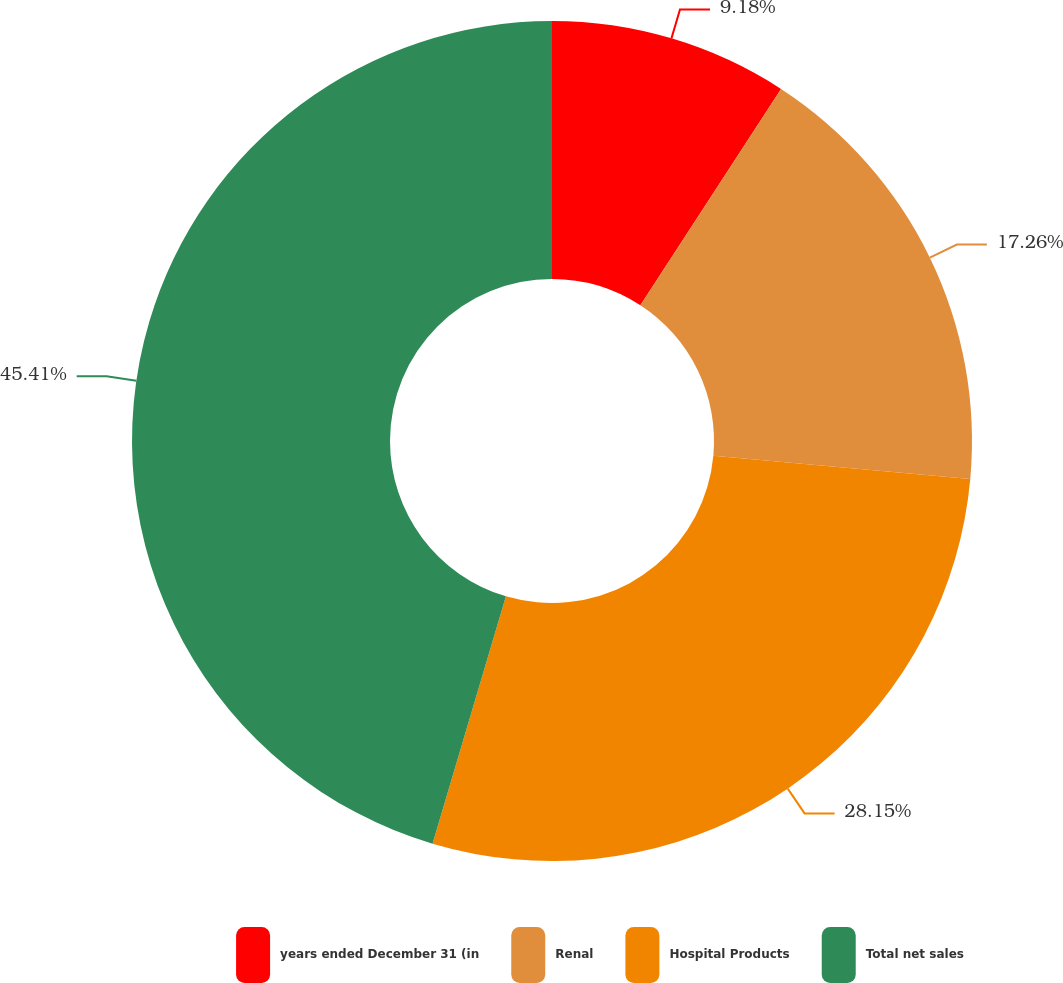Convert chart to OTSL. <chart><loc_0><loc_0><loc_500><loc_500><pie_chart><fcel>years ended December 31 (in<fcel>Renal<fcel>Hospital Products<fcel>Total net sales<nl><fcel>9.18%<fcel>17.26%<fcel>28.15%<fcel>45.41%<nl></chart> 